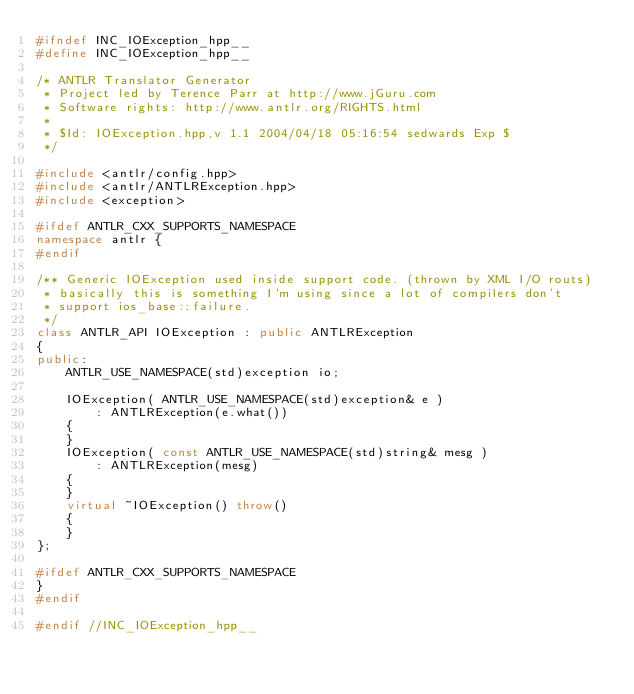Convert code to text. <code><loc_0><loc_0><loc_500><loc_500><_C++_>#ifndef INC_IOException_hpp__
#define INC_IOException_hpp__

/* ANTLR Translator Generator
 * Project led by Terence Parr at http://www.jGuru.com
 * Software rights: http://www.antlr.org/RIGHTS.html
 *
 * $Id: IOException.hpp,v 1.1 2004/04/18 05:16:54 sedwards Exp $
 */

#include <antlr/config.hpp>
#include <antlr/ANTLRException.hpp>
#include <exception>

#ifdef ANTLR_CXX_SUPPORTS_NAMESPACE
namespace antlr {
#endif

/** Generic IOException used inside support code. (thrown by XML I/O routs)
 * basically this is something I'm using since a lot of compilers don't
 * support ios_base::failure.
 */
class ANTLR_API IOException : public ANTLRException
{
public:
	ANTLR_USE_NAMESPACE(std)exception io;

	IOException( ANTLR_USE_NAMESPACE(std)exception& e )
		: ANTLRException(e.what())
	{
	}
	IOException( const ANTLR_USE_NAMESPACE(std)string& mesg )
		: ANTLRException(mesg)
	{
	}
	virtual ~IOException() throw()
	{
	}
};

#ifdef ANTLR_CXX_SUPPORTS_NAMESPACE
}
#endif

#endif //INC_IOException_hpp__
</code> 